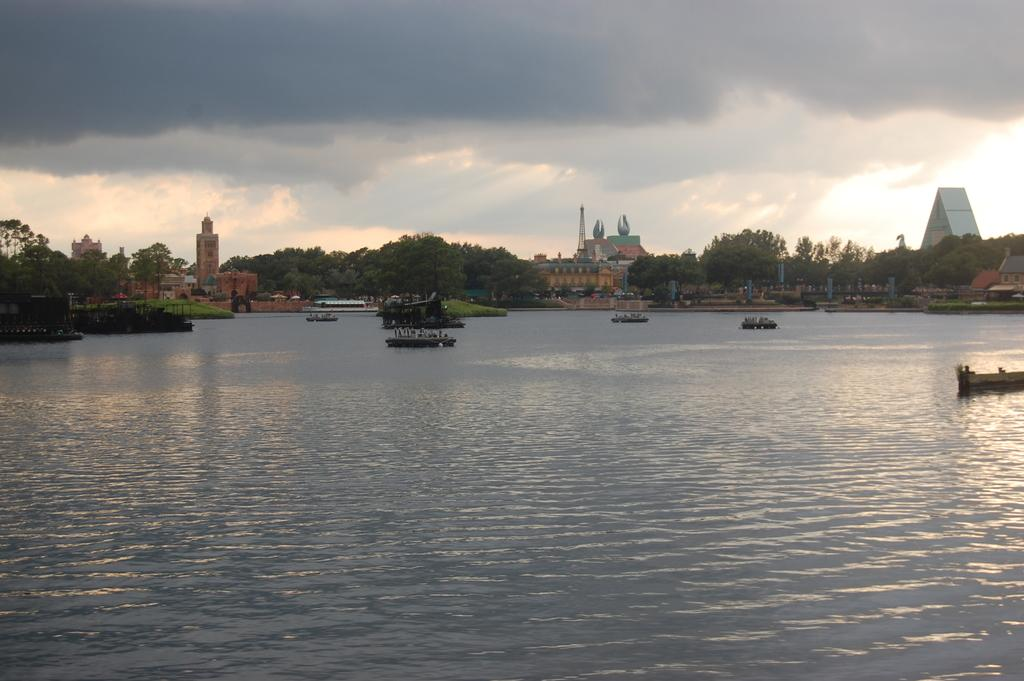What is on the water in the image? There are boats on the water in the image. What can be seen in the background of the image? There are trees, buildings, towers, and poles in the background of the image. What is visible in the sky at the top of the image? There are clouds visible in the sky at the top of the image. What type of net is being used to catch fish in the image? There is no net present in the image; it features boats on the water and various structures in the background. Can you hear the sound of a guitar being played in the image? There is no guitar or any sound present in the image, as it is a still photograph. 